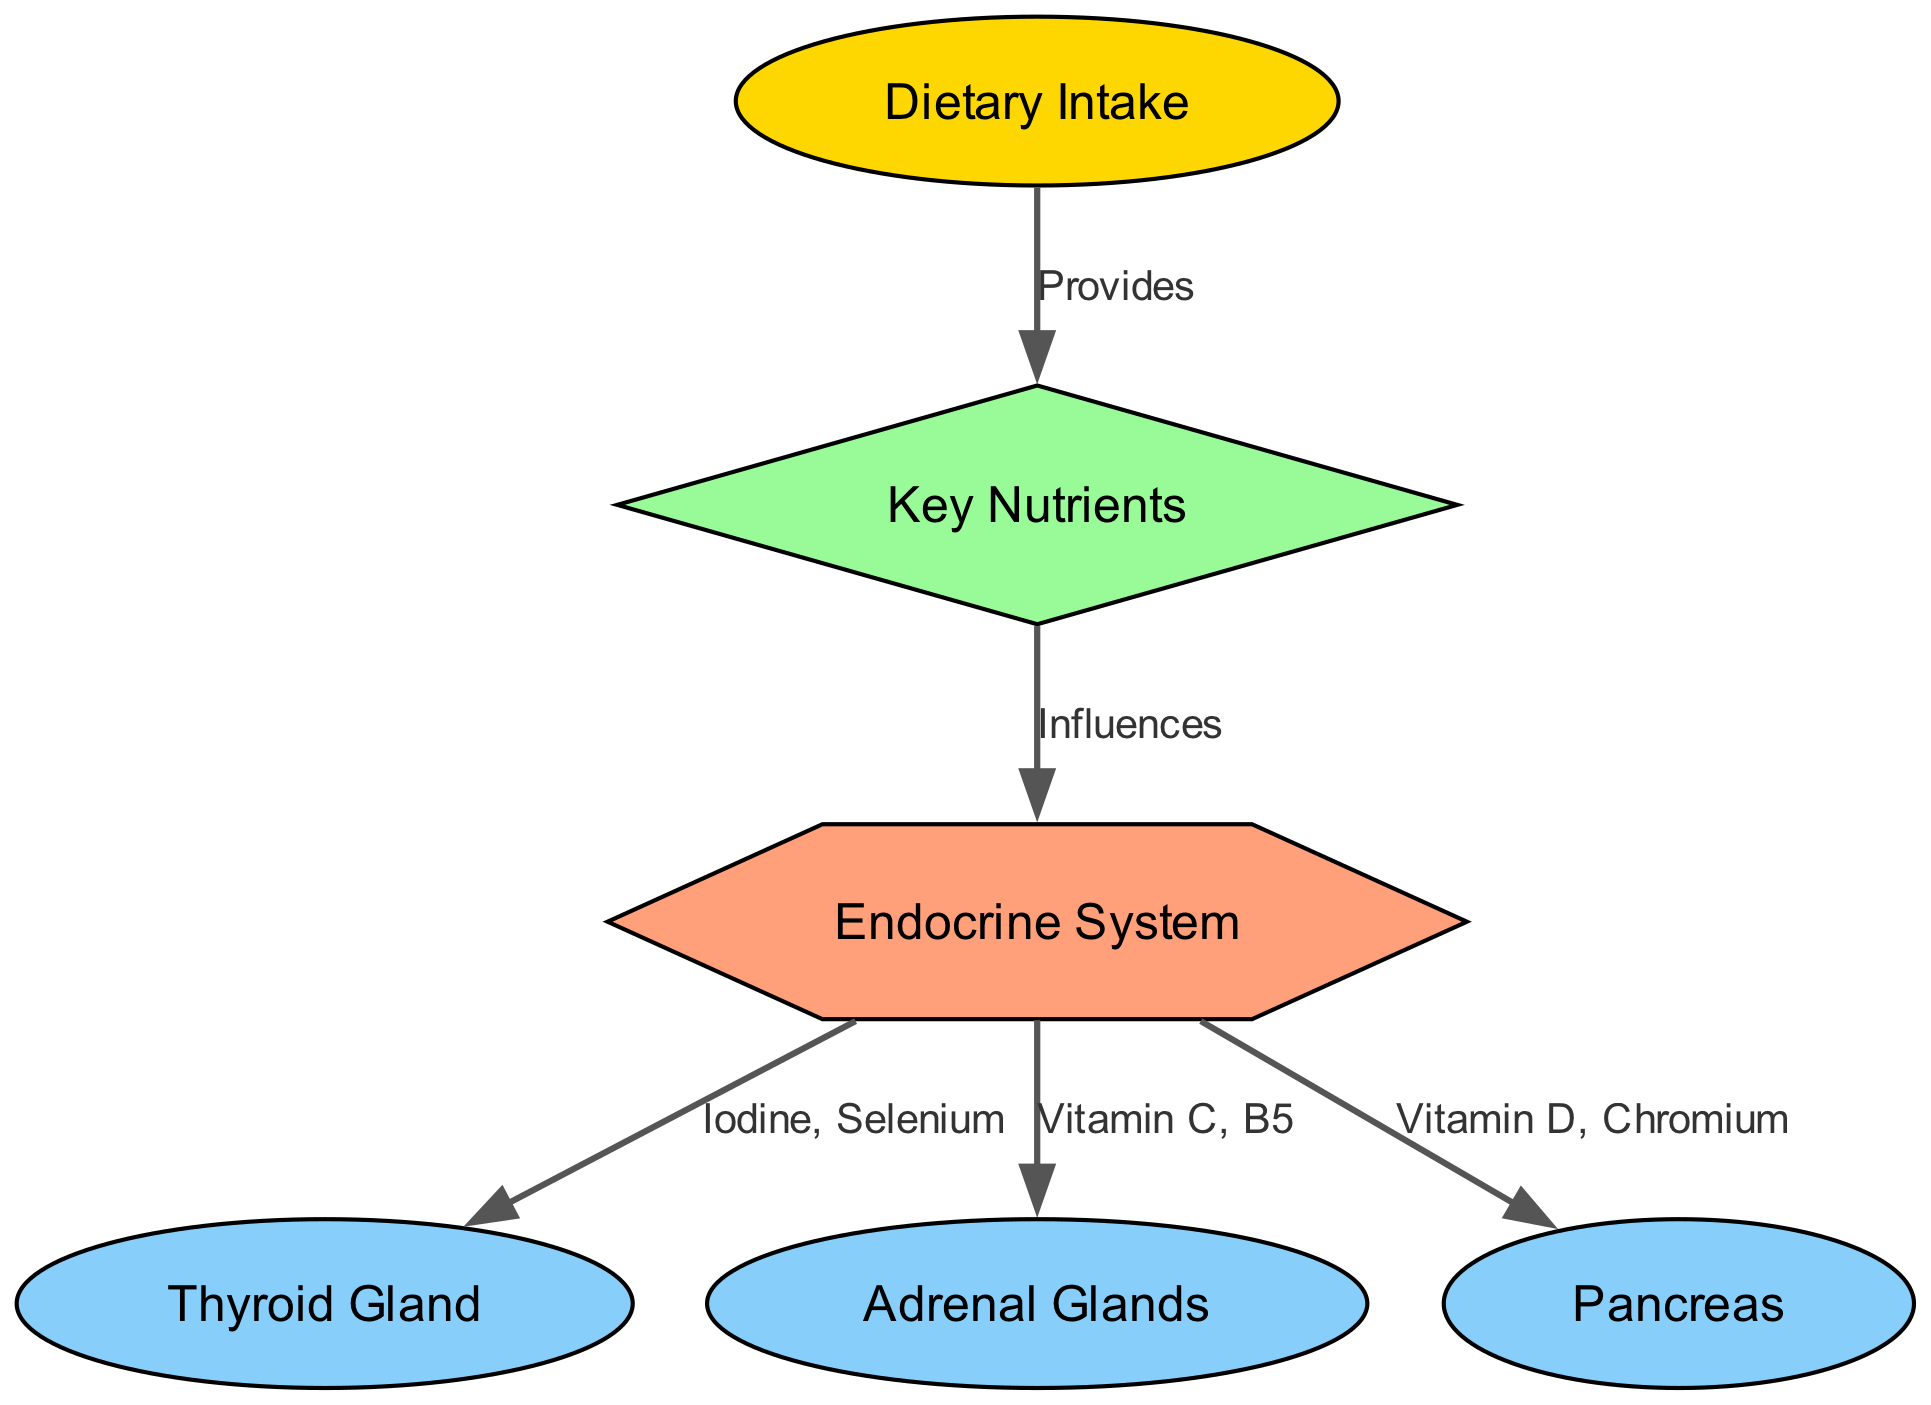What are the three primary glands represented in the diagram? The diagram outlines three glands: the Thyroid Gland, the Adrenal Glands, and the Pancreas. These are explicitly labeled as nodes in the diagram, which identifies them as part of the endocrine system.
Answer: Thyroid Gland, Adrenal Glands, Pancreas How many nodes are present in the diagram? The diagram has a total of six distinct nodes, which include Dietary Intake, Key Nutrients, Endocrine System, Thyroid Gland, Adrenal Glands, and Pancreas. By counting these nodes, which are labeled, one can determine the total.
Answer: 6 What influences the endocrine system according to the diagram? The diagram illustrates that Key Nutrients are what influence the Endocrine System. This relationship is represented by an edge connecting the two nodes, clearly showing that nutrients play a critical role in hormonal function.
Answer: Key Nutrients Which nutrient is linked to the thyroid gland from the endocrine system? The diagram specifies that Iodine and Selenium are linked to the Thyroid Gland through the Edocrine System. This relationship is mentioned as an edge from the endocrine node to the thyroid node, highlighting the importance of these nutrients.
Answer: Iodine, Selenium Name a nutrient associated with the adrenal glands from the diagram. According to the diagram, Vitamin C and B5 are nutrients associated with the Adrenal Glands. This association is visible through the connecting edge that indicates the specific nutrients impacting the adrenal glands.
Answer: Vitamin C, B5 What does the diet provide according to the schematic representation? The diagram indicates that Dietary Intake provides Key Nutrients. This relationship shows how dietary choices significantly contribute to the intake of essential vitamins and minerals that influence hormonal activity.
Answer: Key Nutrients What shape is the "Endocrine System" node? In the diagram, the Endocrine System node is shaped like a hexagon. This specific geometric shape distinguishes it from other nodes, each with their unique shapes.
Answer: Hexagon How many edges are there in the diagram? The diagram displays a total of five edges, each representing the relationships between various nodes, such as dietary intake, nutrients, and different endocrine glands. This amount can be confirmed by counting the connections drawn among the nodes.
Answer: 5 